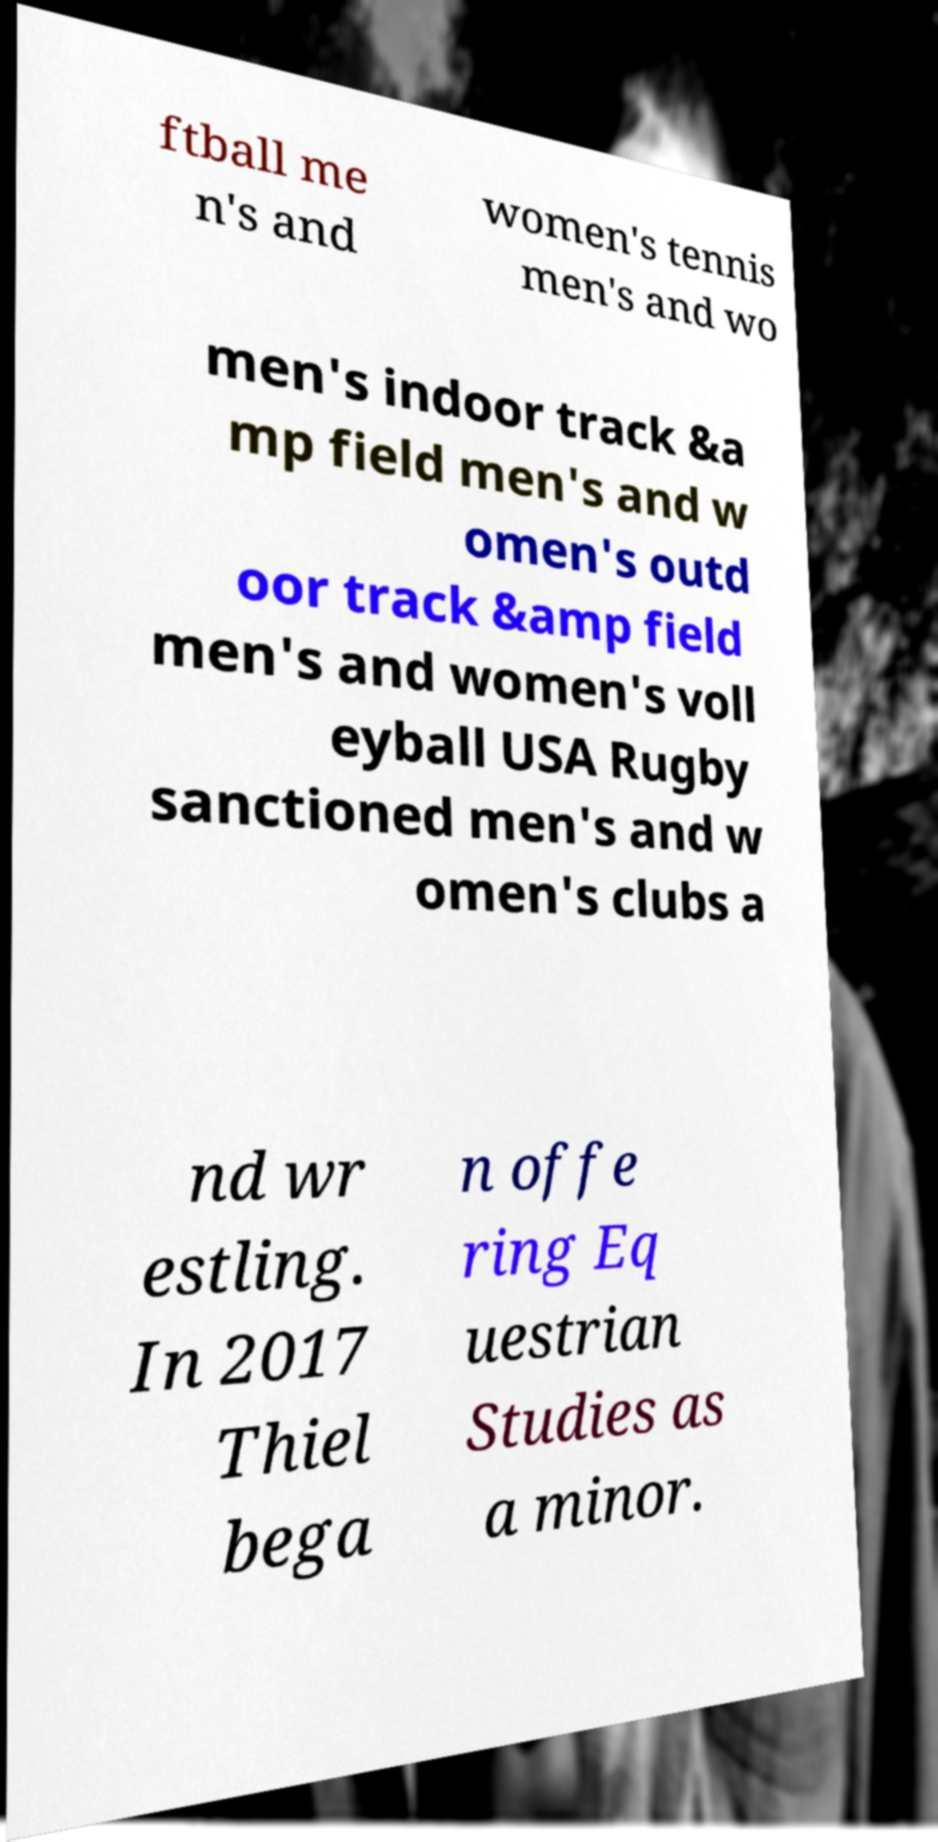Please identify and transcribe the text found in this image. ftball me n's and women's tennis men's and wo men's indoor track &a mp field men's and w omen's outd oor track &amp field men's and women's voll eyball USA Rugby sanctioned men's and w omen's clubs a nd wr estling. In 2017 Thiel bega n offe ring Eq uestrian Studies as a minor. 